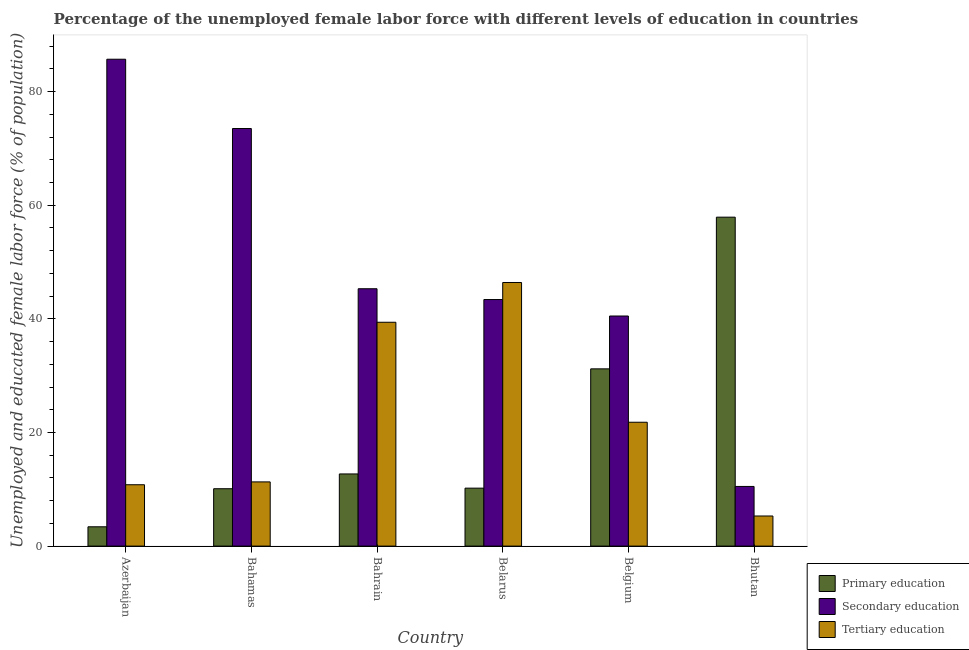Are the number of bars per tick equal to the number of legend labels?
Keep it short and to the point. Yes. Are the number of bars on each tick of the X-axis equal?
Offer a terse response. Yes. What is the label of the 1st group of bars from the left?
Your answer should be compact. Azerbaijan. In how many cases, is the number of bars for a given country not equal to the number of legend labels?
Provide a short and direct response. 0. What is the percentage of female labor force who received secondary education in Bahamas?
Make the answer very short. 73.5. Across all countries, what is the maximum percentage of female labor force who received secondary education?
Offer a terse response. 85.7. Across all countries, what is the minimum percentage of female labor force who received tertiary education?
Offer a terse response. 5.3. In which country was the percentage of female labor force who received tertiary education maximum?
Make the answer very short. Belarus. In which country was the percentage of female labor force who received tertiary education minimum?
Keep it short and to the point. Bhutan. What is the total percentage of female labor force who received secondary education in the graph?
Your answer should be compact. 298.9. What is the difference between the percentage of female labor force who received secondary education in Azerbaijan and that in Bhutan?
Ensure brevity in your answer.  75.2. What is the difference between the percentage of female labor force who received secondary education in Azerbaijan and the percentage of female labor force who received primary education in Bhutan?
Offer a terse response. 27.8. What is the average percentage of female labor force who received primary education per country?
Your answer should be compact. 20.92. What is the difference between the percentage of female labor force who received primary education and percentage of female labor force who received tertiary education in Belgium?
Your answer should be very brief. 9.4. What is the ratio of the percentage of female labor force who received tertiary education in Bahamas to that in Bahrain?
Give a very brief answer. 0.29. Is the percentage of female labor force who received tertiary education in Azerbaijan less than that in Bahrain?
Offer a very short reply. Yes. Is the difference between the percentage of female labor force who received secondary education in Azerbaijan and Belarus greater than the difference between the percentage of female labor force who received tertiary education in Azerbaijan and Belarus?
Ensure brevity in your answer.  Yes. What is the difference between the highest and the second highest percentage of female labor force who received primary education?
Provide a succinct answer. 26.7. What is the difference between the highest and the lowest percentage of female labor force who received secondary education?
Ensure brevity in your answer.  75.2. In how many countries, is the percentage of female labor force who received tertiary education greater than the average percentage of female labor force who received tertiary education taken over all countries?
Offer a very short reply. 2. Is the sum of the percentage of female labor force who received tertiary education in Belgium and Bhutan greater than the maximum percentage of female labor force who received secondary education across all countries?
Provide a short and direct response. No. What does the 2nd bar from the left in Azerbaijan represents?
Provide a succinct answer. Secondary education. What does the 2nd bar from the right in Azerbaijan represents?
Ensure brevity in your answer.  Secondary education. How many bars are there?
Your response must be concise. 18. Are all the bars in the graph horizontal?
Keep it short and to the point. No. What is the difference between two consecutive major ticks on the Y-axis?
Make the answer very short. 20. Are the values on the major ticks of Y-axis written in scientific E-notation?
Offer a very short reply. No. Does the graph contain any zero values?
Provide a succinct answer. No. Where does the legend appear in the graph?
Offer a terse response. Bottom right. How are the legend labels stacked?
Provide a short and direct response. Vertical. What is the title of the graph?
Provide a short and direct response. Percentage of the unemployed female labor force with different levels of education in countries. What is the label or title of the Y-axis?
Make the answer very short. Unemployed and educated female labor force (% of population). What is the Unemployed and educated female labor force (% of population) of Primary education in Azerbaijan?
Your answer should be very brief. 3.4. What is the Unemployed and educated female labor force (% of population) of Secondary education in Azerbaijan?
Provide a succinct answer. 85.7. What is the Unemployed and educated female labor force (% of population) in Tertiary education in Azerbaijan?
Provide a short and direct response. 10.8. What is the Unemployed and educated female labor force (% of population) of Primary education in Bahamas?
Make the answer very short. 10.1. What is the Unemployed and educated female labor force (% of population) of Secondary education in Bahamas?
Your answer should be very brief. 73.5. What is the Unemployed and educated female labor force (% of population) of Tertiary education in Bahamas?
Your response must be concise. 11.3. What is the Unemployed and educated female labor force (% of population) in Primary education in Bahrain?
Make the answer very short. 12.7. What is the Unemployed and educated female labor force (% of population) in Secondary education in Bahrain?
Provide a short and direct response. 45.3. What is the Unemployed and educated female labor force (% of population) of Tertiary education in Bahrain?
Offer a very short reply. 39.4. What is the Unemployed and educated female labor force (% of population) of Primary education in Belarus?
Your response must be concise. 10.2. What is the Unemployed and educated female labor force (% of population) in Secondary education in Belarus?
Your answer should be compact. 43.4. What is the Unemployed and educated female labor force (% of population) of Tertiary education in Belarus?
Keep it short and to the point. 46.4. What is the Unemployed and educated female labor force (% of population) of Primary education in Belgium?
Make the answer very short. 31.2. What is the Unemployed and educated female labor force (% of population) in Secondary education in Belgium?
Provide a succinct answer. 40.5. What is the Unemployed and educated female labor force (% of population) in Tertiary education in Belgium?
Provide a succinct answer. 21.8. What is the Unemployed and educated female labor force (% of population) in Primary education in Bhutan?
Provide a succinct answer. 57.9. What is the Unemployed and educated female labor force (% of population) of Tertiary education in Bhutan?
Your response must be concise. 5.3. Across all countries, what is the maximum Unemployed and educated female labor force (% of population) in Primary education?
Your answer should be very brief. 57.9. Across all countries, what is the maximum Unemployed and educated female labor force (% of population) of Secondary education?
Keep it short and to the point. 85.7. Across all countries, what is the maximum Unemployed and educated female labor force (% of population) of Tertiary education?
Provide a short and direct response. 46.4. Across all countries, what is the minimum Unemployed and educated female labor force (% of population) of Primary education?
Offer a terse response. 3.4. Across all countries, what is the minimum Unemployed and educated female labor force (% of population) in Secondary education?
Offer a very short reply. 10.5. Across all countries, what is the minimum Unemployed and educated female labor force (% of population) in Tertiary education?
Keep it short and to the point. 5.3. What is the total Unemployed and educated female labor force (% of population) of Primary education in the graph?
Provide a succinct answer. 125.5. What is the total Unemployed and educated female labor force (% of population) of Secondary education in the graph?
Provide a succinct answer. 298.9. What is the total Unemployed and educated female labor force (% of population) in Tertiary education in the graph?
Give a very brief answer. 135. What is the difference between the Unemployed and educated female labor force (% of population) in Primary education in Azerbaijan and that in Bahamas?
Make the answer very short. -6.7. What is the difference between the Unemployed and educated female labor force (% of population) of Tertiary education in Azerbaijan and that in Bahamas?
Keep it short and to the point. -0.5. What is the difference between the Unemployed and educated female labor force (% of population) of Secondary education in Azerbaijan and that in Bahrain?
Your answer should be compact. 40.4. What is the difference between the Unemployed and educated female labor force (% of population) of Tertiary education in Azerbaijan and that in Bahrain?
Provide a short and direct response. -28.6. What is the difference between the Unemployed and educated female labor force (% of population) in Secondary education in Azerbaijan and that in Belarus?
Provide a succinct answer. 42.3. What is the difference between the Unemployed and educated female labor force (% of population) in Tertiary education in Azerbaijan and that in Belarus?
Offer a very short reply. -35.6. What is the difference between the Unemployed and educated female labor force (% of population) of Primary education in Azerbaijan and that in Belgium?
Offer a very short reply. -27.8. What is the difference between the Unemployed and educated female labor force (% of population) in Secondary education in Azerbaijan and that in Belgium?
Provide a succinct answer. 45.2. What is the difference between the Unemployed and educated female labor force (% of population) of Tertiary education in Azerbaijan and that in Belgium?
Provide a short and direct response. -11. What is the difference between the Unemployed and educated female labor force (% of population) of Primary education in Azerbaijan and that in Bhutan?
Your answer should be very brief. -54.5. What is the difference between the Unemployed and educated female labor force (% of population) in Secondary education in Azerbaijan and that in Bhutan?
Give a very brief answer. 75.2. What is the difference between the Unemployed and educated female labor force (% of population) in Tertiary education in Azerbaijan and that in Bhutan?
Your response must be concise. 5.5. What is the difference between the Unemployed and educated female labor force (% of population) in Primary education in Bahamas and that in Bahrain?
Provide a succinct answer. -2.6. What is the difference between the Unemployed and educated female labor force (% of population) of Secondary education in Bahamas and that in Bahrain?
Provide a short and direct response. 28.2. What is the difference between the Unemployed and educated female labor force (% of population) of Tertiary education in Bahamas and that in Bahrain?
Keep it short and to the point. -28.1. What is the difference between the Unemployed and educated female labor force (% of population) of Primary education in Bahamas and that in Belarus?
Your answer should be compact. -0.1. What is the difference between the Unemployed and educated female labor force (% of population) in Secondary education in Bahamas and that in Belarus?
Your response must be concise. 30.1. What is the difference between the Unemployed and educated female labor force (% of population) in Tertiary education in Bahamas and that in Belarus?
Offer a very short reply. -35.1. What is the difference between the Unemployed and educated female labor force (% of population) in Primary education in Bahamas and that in Belgium?
Provide a short and direct response. -21.1. What is the difference between the Unemployed and educated female labor force (% of population) in Primary education in Bahamas and that in Bhutan?
Make the answer very short. -47.8. What is the difference between the Unemployed and educated female labor force (% of population) in Tertiary education in Bahamas and that in Bhutan?
Keep it short and to the point. 6. What is the difference between the Unemployed and educated female labor force (% of population) of Primary education in Bahrain and that in Belarus?
Offer a terse response. 2.5. What is the difference between the Unemployed and educated female labor force (% of population) of Tertiary education in Bahrain and that in Belarus?
Offer a very short reply. -7. What is the difference between the Unemployed and educated female labor force (% of population) in Primary education in Bahrain and that in Belgium?
Give a very brief answer. -18.5. What is the difference between the Unemployed and educated female labor force (% of population) in Tertiary education in Bahrain and that in Belgium?
Ensure brevity in your answer.  17.6. What is the difference between the Unemployed and educated female labor force (% of population) in Primary education in Bahrain and that in Bhutan?
Provide a succinct answer. -45.2. What is the difference between the Unemployed and educated female labor force (% of population) in Secondary education in Bahrain and that in Bhutan?
Offer a very short reply. 34.8. What is the difference between the Unemployed and educated female labor force (% of population) of Tertiary education in Bahrain and that in Bhutan?
Make the answer very short. 34.1. What is the difference between the Unemployed and educated female labor force (% of population) of Primary education in Belarus and that in Belgium?
Provide a succinct answer. -21. What is the difference between the Unemployed and educated female labor force (% of population) of Tertiary education in Belarus and that in Belgium?
Offer a terse response. 24.6. What is the difference between the Unemployed and educated female labor force (% of population) in Primary education in Belarus and that in Bhutan?
Ensure brevity in your answer.  -47.7. What is the difference between the Unemployed and educated female labor force (% of population) of Secondary education in Belarus and that in Bhutan?
Offer a terse response. 32.9. What is the difference between the Unemployed and educated female labor force (% of population) of Tertiary education in Belarus and that in Bhutan?
Provide a short and direct response. 41.1. What is the difference between the Unemployed and educated female labor force (% of population) of Primary education in Belgium and that in Bhutan?
Offer a terse response. -26.7. What is the difference between the Unemployed and educated female labor force (% of population) of Secondary education in Belgium and that in Bhutan?
Provide a short and direct response. 30. What is the difference between the Unemployed and educated female labor force (% of population) in Tertiary education in Belgium and that in Bhutan?
Make the answer very short. 16.5. What is the difference between the Unemployed and educated female labor force (% of population) of Primary education in Azerbaijan and the Unemployed and educated female labor force (% of population) of Secondary education in Bahamas?
Give a very brief answer. -70.1. What is the difference between the Unemployed and educated female labor force (% of population) in Secondary education in Azerbaijan and the Unemployed and educated female labor force (% of population) in Tertiary education in Bahamas?
Ensure brevity in your answer.  74.4. What is the difference between the Unemployed and educated female labor force (% of population) of Primary education in Azerbaijan and the Unemployed and educated female labor force (% of population) of Secondary education in Bahrain?
Provide a short and direct response. -41.9. What is the difference between the Unemployed and educated female labor force (% of population) in Primary education in Azerbaijan and the Unemployed and educated female labor force (% of population) in Tertiary education in Bahrain?
Give a very brief answer. -36. What is the difference between the Unemployed and educated female labor force (% of population) of Secondary education in Azerbaijan and the Unemployed and educated female labor force (% of population) of Tertiary education in Bahrain?
Provide a succinct answer. 46.3. What is the difference between the Unemployed and educated female labor force (% of population) of Primary education in Azerbaijan and the Unemployed and educated female labor force (% of population) of Tertiary education in Belarus?
Your answer should be compact. -43. What is the difference between the Unemployed and educated female labor force (% of population) of Secondary education in Azerbaijan and the Unemployed and educated female labor force (% of population) of Tertiary education in Belarus?
Your response must be concise. 39.3. What is the difference between the Unemployed and educated female labor force (% of population) of Primary education in Azerbaijan and the Unemployed and educated female labor force (% of population) of Secondary education in Belgium?
Ensure brevity in your answer.  -37.1. What is the difference between the Unemployed and educated female labor force (% of population) in Primary education in Azerbaijan and the Unemployed and educated female labor force (% of population) in Tertiary education in Belgium?
Provide a short and direct response. -18.4. What is the difference between the Unemployed and educated female labor force (% of population) of Secondary education in Azerbaijan and the Unemployed and educated female labor force (% of population) of Tertiary education in Belgium?
Make the answer very short. 63.9. What is the difference between the Unemployed and educated female labor force (% of population) in Primary education in Azerbaijan and the Unemployed and educated female labor force (% of population) in Tertiary education in Bhutan?
Give a very brief answer. -1.9. What is the difference between the Unemployed and educated female labor force (% of population) of Secondary education in Azerbaijan and the Unemployed and educated female labor force (% of population) of Tertiary education in Bhutan?
Offer a very short reply. 80.4. What is the difference between the Unemployed and educated female labor force (% of population) in Primary education in Bahamas and the Unemployed and educated female labor force (% of population) in Secondary education in Bahrain?
Ensure brevity in your answer.  -35.2. What is the difference between the Unemployed and educated female labor force (% of population) of Primary education in Bahamas and the Unemployed and educated female labor force (% of population) of Tertiary education in Bahrain?
Your answer should be very brief. -29.3. What is the difference between the Unemployed and educated female labor force (% of population) of Secondary education in Bahamas and the Unemployed and educated female labor force (% of population) of Tertiary education in Bahrain?
Provide a succinct answer. 34.1. What is the difference between the Unemployed and educated female labor force (% of population) in Primary education in Bahamas and the Unemployed and educated female labor force (% of population) in Secondary education in Belarus?
Offer a terse response. -33.3. What is the difference between the Unemployed and educated female labor force (% of population) in Primary education in Bahamas and the Unemployed and educated female labor force (% of population) in Tertiary education in Belarus?
Provide a succinct answer. -36.3. What is the difference between the Unemployed and educated female labor force (% of population) of Secondary education in Bahamas and the Unemployed and educated female labor force (% of population) of Tertiary education in Belarus?
Give a very brief answer. 27.1. What is the difference between the Unemployed and educated female labor force (% of population) in Primary education in Bahamas and the Unemployed and educated female labor force (% of population) in Secondary education in Belgium?
Provide a succinct answer. -30.4. What is the difference between the Unemployed and educated female labor force (% of population) in Secondary education in Bahamas and the Unemployed and educated female labor force (% of population) in Tertiary education in Belgium?
Offer a terse response. 51.7. What is the difference between the Unemployed and educated female labor force (% of population) in Secondary education in Bahamas and the Unemployed and educated female labor force (% of population) in Tertiary education in Bhutan?
Offer a terse response. 68.2. What is the difference between the Unemployed and educated female labor force (% of population) in Primary education in Bahrain and the Unemployed and educated female labor force (% of population) in Secondary education in Belarus?
Offer a very short reply. -30.7. What is the difference between the Unemployed and educated female labor force (% of population) in Primary education in Bahrain and the Unemployed and educated female labor force (% of population) in Tertiary education in Belarus?
Your response must be concise. -33.7. What is the difference between the Unemployed and educated female labor force (% of population) in Secondary education in Bahrain and the Unemployed and educated female labor force (% of population) in Tertiary education in Belarus?
Provide a short and direct response. -1.1. What is the difference between the Unemployed and educated female labor force (% of population) in Primary education in Bahrain and the Unemployed and educated female labor force (% of population) in Secondary education in Belgium?
Give a very brief answer. -27.8. What is the difference between the Unemployed and educated female labor force (% of population) in Secondary education in Bahrain and the Unemployed and educated female labor force (% of population) in Tertiary education in Belgium?
Provide a succinct answer. 23.5. What is the difference between the Unemployed and educated female labor force (% of population) in Secondary education in Bahrain and the Unemployed and educated female labor force (% of population) in Tertiary education in Bhutan?
Provide a succinct answer. 40. What is the difference between the Unemployed and educated female labor force (% of population) of Primary education in Belarus and the Unemployed and educated female labor force (% of population) of Secondary education in Belgium?
Ensure brevity in your answer.  -30.3. What is the difference between the Unemployed and educated female labor force (% of population) of Secondary education in Belarus and the Unemployed and educated female labor force (% of population) of Tertiary education in Belgium?
Your answer should be compact. 21.6. What is the difference between the Unemployed and educated female labor force (% of population) in Secondary education in Belarus and the Unemployed and educated female labor force (% of population) in Tertiary education in Bhutan?
Ensure brevity in your answer.  38.1. What is the difference between the Unemployed and educated female labor force (% of population) in Primary education in Belgium and the Unemployed and educated female labor force (% of population) in Secondary education in Bhutan?
Provide a succinct answer. 20.7. What is the difference between the Unemployed and educated female labor force (% of population) of Primary education in Belgium and the Unemployed and educated female labor force (% of population) of Tertiary education in Bhutan?
Your response must be concise. 25.9. What is the difference between the Unemployed and educated female labor force (% of population) of Secondary education in Belgium and the Unemployed and educated female labor force (% of population) of Tertiary education in Bhutan?
Give a very brief answer. 35.2. What is the average Unemployed and educated female labor force (% of population) in Primary education per country?
Offer a very short reply. 20.92. What is the average Unemployed and educated female labor force (% of population) in Secondary education per country?
Your answer should be compact. 49.82. What is the average Unemployed and educated female labor force (% of population) of Tertiary education per country?
Your response must be concise. 22.5. What is the difference between the Unemployed and educated female labor force (% of population) of Primary education and Unemployed and educated female labor force (% of population) of Secondary education in Azerbaijan?
Provide a succinct answer. -82.3. What is the difference between the Unemployed and educated female labor force (% of population) in Secondary education and Unemployed and educated female labor force (% of population) in Tertiary education in Azerbaijan?
Your answer should be very brief. 74.9. What is the difference between the Unemployed and educated female labor force (% of population) in Primary education and Unemployed and educated female labor force (% of population) in Secondary education in Bahamas?
Provide a succinct answer. -63.4. What is the difference between the Unemployed and educated female labor force (% of population) in Primary education and Unemployed and educated female labor force (% of population) in Tertiary education in Bahamas?
Keep it short and to the point. -1.2. What is the difference between the Unemployed and educated female labor force (% of population) of Secondary education and Unemployed and educated female labor force (% of population) of Tertiary education in Bahamas?
Ensure brevity in your answer.  62.2. What is the difference between the Unemployed and educated female labor force (% of population) in Primary education and Unemployed and educated female labor force (% of population) in Secondary education in Bahrain?
Provide a succinct answer. -32.6. What is the difference between the Unemployed and educated female labor force (% of population) of Primary education and Unemployed and educated female labor force (% of population) of Tertiary education in Bahrain?
Keep it short and to the point. -26.7. What is the difference between the Unemployed and educated female labor force (% of population) in Primary education and Unemployed and educated female labor force (% of population) in Secondary education in Belarus?
Offer a very short reply. -33.2. What is the difference between the Unemployed and educated female labor force (% of population) of Primary education and Unemployed and educated female labor force (% of population) of Tertiary education in Belarus?
Your answer should be very brief. -36.2. What is the difference between the Unemployed and educated female labor force (% of population) in Secondary education and Unemployed and educated female labor force (% of population) in Tertiary education in Belarus?
Ensure brevity in your answer.  -3. What is the difference between the Unemployed and educated female labor force (% of population) of Primary education and Unemployed and educated female labor force (% of population) of Secondary education in Belgium?
Offer a terse response. -9.3. What is the difference between the Unemployed and educated female labor force (% of population) of Secondary education and Unemployed and educated female labor force (% of population) of Tertiary education in Belgium?
Your answer should be very brief. 18.7. What is the difference between the Unemployed and educated female labor force (% of population) in Primary education and Unemployed and educated female labor force (% of population) in Secondary education in Bhutan?
Ensure brevity in your answer.  47.4. What is the difference between the Unemployed and educated female labor force (% of population) in Primary education and Unemployed and educated female labor force (% of population) in Tertiary education in Bhutan?
Give a very brief answer. 52.6. What is the difference between the Unemployed and educated female labor force (% of population) in Secondary education and Unemployed and educated female labor force (% of population) in Tertiary education in Bhutan?
Offer a very short reply. 5.2. What is the ratio of the Unemployed and educated female labor force (% of population) in Primary education in Azerbaijan to that in Bahamas?
Provide a succinct answer. 0.34. What is the ratio of the Unemployed and educated female labor force (% of population) in Secondary education in Azerbaijan to that in Bahamas?
Your answer should be very brief. 1.17. What is the ratio of the Unemployed and educated female labor force (% of population) in Tertiary education in Azerbaijan to that in Bahamas?
Ensure brevity in your answer.  0.96. What is the ratio of the Unemployed and educated female labor force (% of population) of Primary education in Azerbaijan to that in Bahrain?
Provide a short and direct response. 0.27. What is the ratio of the Unemployed and educated female labor force (% of population) of Secondary education in Azerbaijan to that in Bahrain?
Offer a terse response. 1.89. What is the ratio of the Unemployed and educated female labor force (% of population) in Tertiary education in Azerbaijan to that in Bahrain?
Your response must be concise. 0.27. What is the ratio of the Unemployed and educated female labor force (% of population) of Secondary education in Azerbaijan to that in Belarus?
Offer a terse response. 1.97. What is the ratio of the Unemployed and educated female labor force (% of population) in Tertiary education in Azerbaijan to that in Belarus?
Offer a terse response. 0.23. What is the ratio of the Unemployed and educated female labor force (% of population) in Primary education in Azerbaijan to that in Belgium?
Keep it short and to the point. 0.11. What is the ratio of the Unemployed and educated female labor force (% of population) of Secondary education in Azerbaijan to that in Belgium?
Give a very brief answer. 2.12. What is the ratio of the Unemployed and educated female labor force (% of population) of Tertiary education in Azerbaijan to that in Belgium?
Provide a short and direct response. 0.5. What is the ratio of the Unemployed and educated female labor force (% of population) in Primary education in Azerbaijan to that in Bhutan?
Provide a succinct answer. 0.06. What is the ratio of the Unemployed and educated female labor force (% of population) in Secondary education in Azerbaijan to that in Bhutan?
Your answer should be compact. 8.16. What is the ratio of the Unemployed and educated female labor force (% of population) of Tertiary education in Azerbaijan to that in Bhutan?
Provide a short and direct response. 2.04. What is the ratio of the Unemployed and educated female labor force (% of population) of Primary education in Bahamas to that in Bahrain?
Make the answer very short. 0.8. What is the ratio of the Unemployed and educated female labor force (% of population) of Secondary education in Bahamas to that in Bahrain?
Provide a succinct answer. 1.62. What is the ratio of the Unemployed and educated female labor force (% of population) in Tertiary education in Bahamas to that in Bahrain?
Provide a succinct answer. 0.29. What is the ratio of the Unemployed and educated female labor force (% of population) in Primary education in Bahamas to that in Belarus?
Offer a terse response. 0.99. What is the ratio of the Unemployed and educated female labor force (% of population) in Secondary education in Bahamas to that in Belarus?
Provide a succinct answer. 1.69. What is the ratio of the Unemployed and educated female labor force (% of population) of Tertiary education in Bahamas to that in Belarus?
Your answer should be compact. 0.24. What is the ratio of the Unemployed and educated female labor force (% of population) of Primary education in Bahamas to that in Belgium?
Your response must be concise. 0.32. What is the ratio of the Unemployed and educated female labor force (% of population) in Secondary education in Bahamas to that in Belgium?
Make the answer very short. 1.81. What is the ratio of the Unemployed and educated female labor force (% of population) in Tertiary education in Bahamas to that in Belgium?
Provide a succinct answer. 0.52. What is the ratio of the Unemployed and educated female labor force (% of population) of Primary education in Bahamas to that in Bhutan?
Provide a short and direct response. 0.17. What is the ratio of the Unemployed and educated female labor force (% of population) of Secondary education in Bahamas to that in Bhutan?
Provide a short and direct response. 7. What is the ratio of the Unemployed and educated female labor force (% of population) of Tertiary education in Bahamas to that in Bhutan?
Ensure brevity in your answer.  2.13. What is the ratio of the Unemployed and educated female labor force (% of population) of Primary education in Bahrain to that in Belarus?
Provide a succinct answer. 1.25. What is the ratio of the Unemployed and educated female labor force (% of population) of Secondary education in Bahrain to that in Belarus?
Offer a terse response. 1.04. What is the ratio of the Unemployed and educated female labor force (% of population) in Tertiary education in Bahrain to that in Belarus?
Offer a terse response. 0.85. What is the ratio of the Unemployed and educated female labor force (% of population) in Primary education in Bahrain to that in Belgium?
Offer a terse response. 0.41. What is the ratio of the Unemployed and educated female labor force (% of population) of Secondary education in Bahrain to that in Belgium?
Ensure brevity in your answer.  1.12. What is the ratio of the Unemployed and educated female labor force (% of population) of Tertiary education in Bahrain to that in Belgium?
Make the answer very short. 1.81. What is the ratio of the Unemployed and educated female labor force (% of population) in Primary education in Bahrain to that in Bhutan?
Keep it short and to the point. 0.22. What is the ratio of the Unemployed and educated female labor force (% of population) of Secondary education in Bahrain to that in Bhutan?
Provide a succinct answer. 4.31. What is the ratio of the Unemployed and educated female labor force (% of population) in Tertiary education in Bahrain to that in Bhutan?
Give a very brief answer. 7.43. What is the ratio of the Unemployed and educated female labor force (% of population) in Primary education in Belarus to that in Belgium?
Ensure brevity in your answer.  0.33. What is the ratio of the Unemployed and educated female labor force (% of population) of Secondary education in Belarus to that in Belgium?
Ensure brevity in your answer.  1.07. What is the ratio of the Unemployed and educated female labor force (% of population) in Tertiary education in Belarus to that in Belgium?
Make the answer very short. 2.13. What is the ratio of the Unemployed and educated female labor force (% of population) of Primary education in Belarus to that in Bhutan?
Make the answer very short. 0.18. What is the ratio of the Unemployed and educated female labor force (% of population) of Secondary education in Belarus to that in Bhutan?
Provide a succinct answer. 4.13. What is the ratio of the Unemployed and educated female labor force (% of population) of Tertiary education in Belarus to that in Bhutan?
Your response must be concise. 8.75. What is the ratio of the Unemployed and educated female labor force (% of population) in Primary education in Belgium to that in Bhutan?
Your answer should be very brief. 0.54. What is the ratio of the Unemployed and educated female labor force (% of population) of Secondary education in Belgium to that in Bhutan?
Keep it short and to the point. 3.86. What is the ratio of the Unemployed and educated female labor force (% of population) of Tertiary education in Belgium to that in Bhutan?
Ensure brevity in your answer.  4.11. What is the difference between the highest and the second highest Unemployed and educated female labor force (% of population) in Primary education?
Your answer should be very brief. 26.7. What is the difference between the highest and the lowest Unemployed and educated female labor force (% of population) in Primary education?
Your answer should be compact. 54.5. What is the difference between the highest and the lowest Unemployed and educated female labor force (% of population) of Secondary education?
Give a very brief answer. 75.2. What is the difference between the highest and the lowest Unemployed and educated female labor force (% of population) in Tertiary education?
Your answer should be very brief. 41.1. 